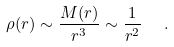Convert formula to latex. <formula><loc_0><loc_0><loc_500><loc_500>\rho ( r ) \sim \frac { M ( r ) } { r ^ { 3 } } \sim \frac { 1 } { r ^ { 2 } } \ \ .</formula> 